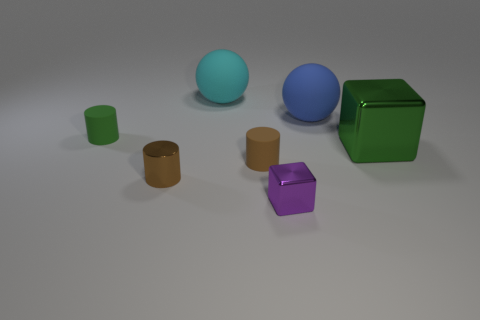The other cylinder that is the same color as the metal cylinder is what size?
Offer a very short reply. Small. There is a cyan object that is the same shape as the blue object; what is its material?
Make the answer very short. Rubber. What number of other large things have the same shape as the blue matte thing?
Your answer should be compact. 1. There is a tiny matte object in front of the tiny green matte thing to the left of the brown metal cylinder; what is its shape?
Ensure brevity in your answer.  Cylinder. Are there fewer small purple shiny objects that are right of the purple shiny cube than purple balls?
Offer a terse response. No. What is the shape of the cyan rubber thing?
Offer a very short reply. Sphere. What is the size of the cube that is to the left of the large blue rubber sphere?
Offer a very short reply. Small. There is a cube that is the same size as the metallic cylinder; what color is it?
Offer a very short reply. Purple. Are there any other tiny cylinders that have the same color as the metal cylinder?
Provide a succinct answer. Yes. Are there fewer green cylinders that are on the right side of the small metal block than big green metallic cubes behind the green shiny block?
Your answer should be very brief. No. 